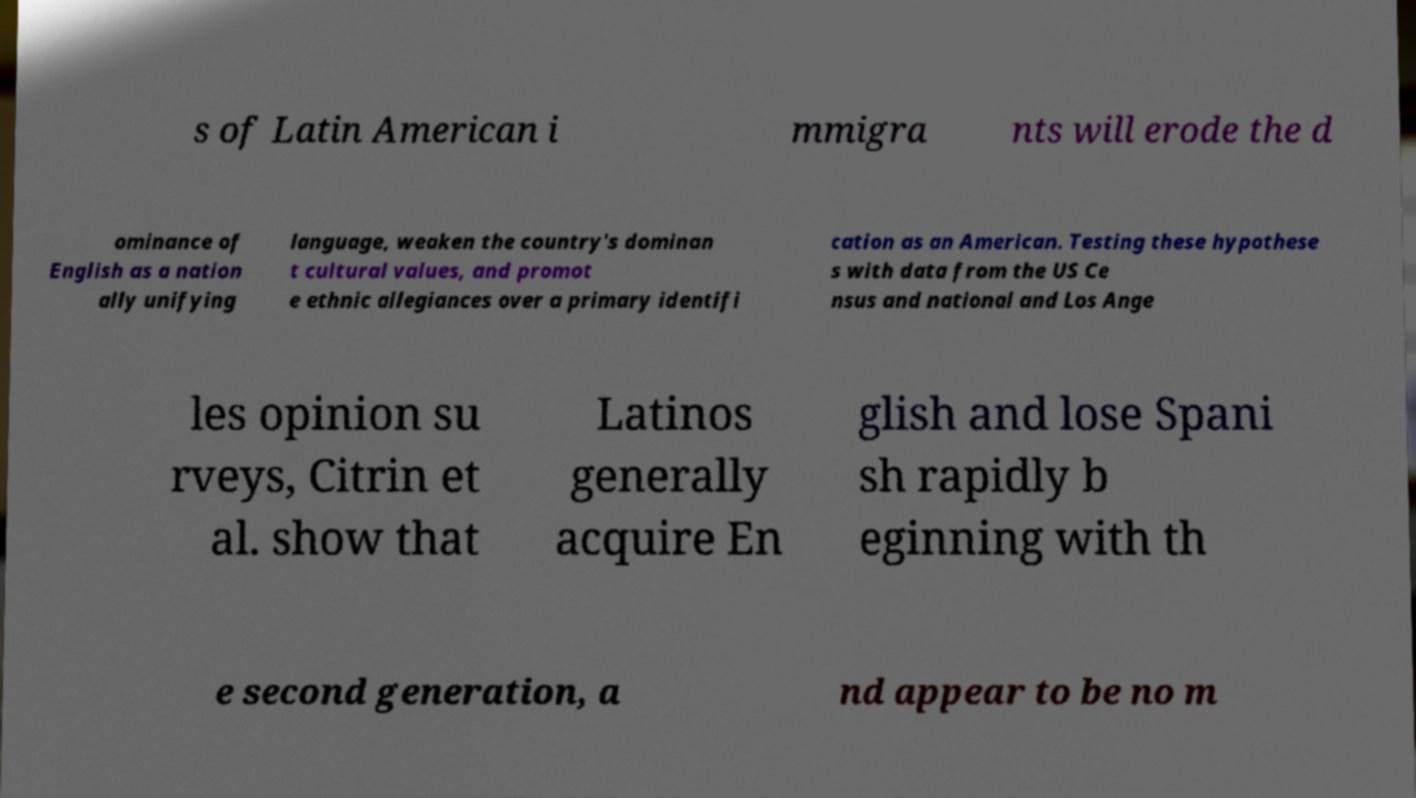Please read and relay the text visible in this image. What does it say? s of Latin American i mmigra nts will erode the d ominance of English as a nation ally unifying language, weaken the country's dominan t cultural values, and promot e ethnic allegiances over a primary identifi cation as an American. Testing these hypothese s with data from the US Ce nsus and national and Los Ange les opinion su rveys, Citrin et al. show that Latinos generally acquire En glish and lose Spani sh rapidly b eginning with th e second generation, a nd appear to be no m 